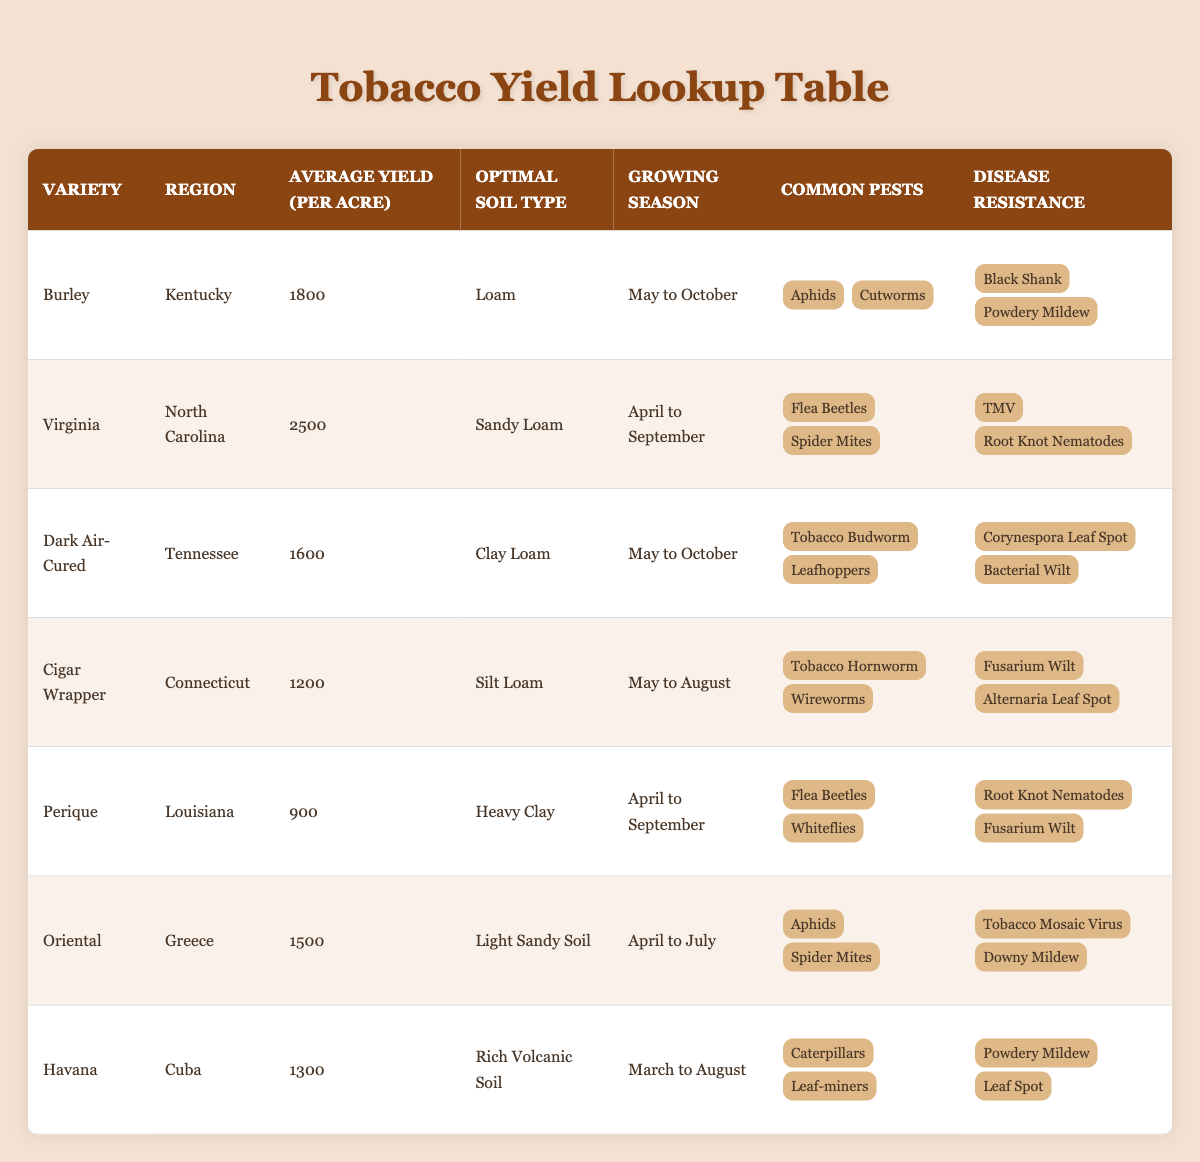What is the average yield per acre for Virginia tobacco? The table shows that the average yield for Virginia tobacco is listed as 2500 per acre.
Answer: 2500 Which region produces the highest average yield per acre for tobacco? By reviewing the average yield values, Virginia has the highest yield at 2500 per acre.
Answer: Virginia Are there any tobacco varieties that are resistant to both Bacterial Wilt and Fusarium Wilt? The table indicates that Perique is resistant to Fusarium Wilt but does not show Bacterial Wilt as a disease for other varieties; hence, no variety is resistant to both.
Answer: No What is the total average yield per acre for Burley and Dark Air-Cured tobacco varieties? Adding the average yields: Burley is 1800 and Dark Air-Cured is 1600, so the total is 1800 + 1600 = 3400.
Answer: 3400 Which tobacco variety has the shortest growing season? The variety with the shortest growing season is Perique, which lasts from April to September (5 months).
Answer: Perique Do any of the tobacco varieties grow in regions with optimal soil type of Clay Loam? The table shows that Dark Air-Cured, which grows in Tennessee, has Clay Loam as the optimal soil type.
Answer: Yes How many varieties of tobacco are resistant to both TMV and Powdery Mildew? The table shows Virginia (TMV), Burley (Powdery Mildew), and no other variety mentioned is resistant to both, so the count is zero.
Answer: 0 What is the average yield of all the tobacco varieties listed in the table? The average yield is calculated as follows: (1800 + 2500 + 1600 + 1200 + 900 + 1500 + 1300) / 7 = 1500.
Answer: 1500 Which region is associated with the Cigar Wrapper variety? From the table, the Cigar Wrapper variety is associated with the region of Connecticut.
Answer: Connecticut 